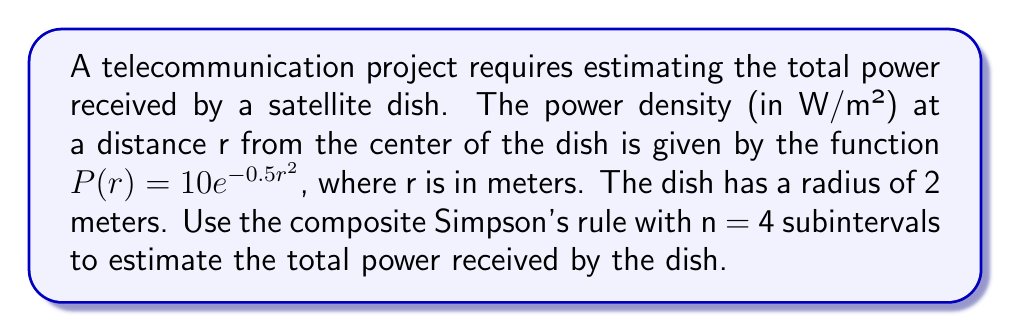Solve this math problem. To solve this problem, we'll follow these steps:

1) The total power received by the dish is given by the integral:

   $$\int_0^2 2\pi r P(r) dr = \int_0^2 2\pi r (10e^{-0.5r^2}) dr$$

2) We'll use the composite Simpson's rule with n = 4 subintervals. The formula is:

   $$\int_a^b f(x)dx \approx \frac{h}{3}[f(x_0) + 4f(x_1) + 2f(x_2) + 4f(x_3) + f(x_4)]$$

   where $h = \frac{b-a}{n}$ and $x_i = a + ih$ for $i = 0, 1, 2, 3, 4$

3) In our case, $a = 0$, $b = 2$, $n = 4$, so $h = \frac{2-0}{4} = 0.5$

4) We need to evaluate $f(r) = 2\pi r (10e^{-0.5r^2})$ at $r = 0, 0.5, 1, 1.5, 2$:

   $f(0) = 0$
   $f(0.5) = 2\pi(0.5)(10e^{-0.5(0.5)^2}) \approx 15.0796$
   $f(1) = 2\pi(1)(10e^{-0.5(1)^2}) \approx 38.1942$
   $f(1.5) = 2\pi(1.5)(10e^{-0.5(1.5)^2}) \approx 51.6566$
   $f(2) = 2\pi(2)(10e^{-0.5(2)^2}) \approx 48.0769$

5) Applying the Simpson's rule:

   $$\frac{0.5}{3}[0 + 4(15.0796) + 2(38.1942) + 4(51.6566) + 48.0769]$$
   $$= \frac{0.5}{3}[0 + 60.3184 + 76.3884 + 206.6264 + 48.0769]$$
   $$= \frac{0.5}{3}(391.4101) \approx 65.2350$$

Therefore, the estimated total power received by the dish is approximately 65.2350 watts.
Answer: 65.2350 W 